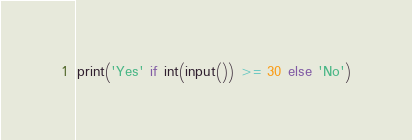Convert code to text. <code><loc_0><loc_0><loc_500><loc_500><_Python_>print('Yes' if int(input()) >= 30 else 'No')
</code> 